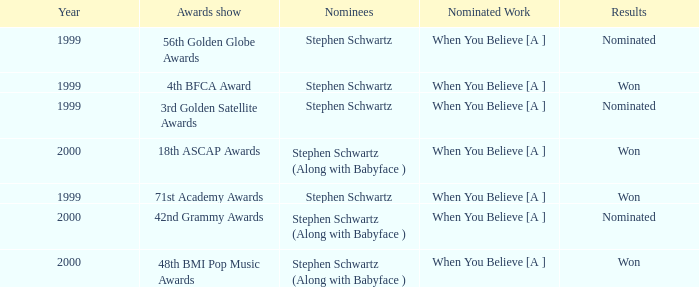What was the results of the 71st Academy Awards show? Won. 